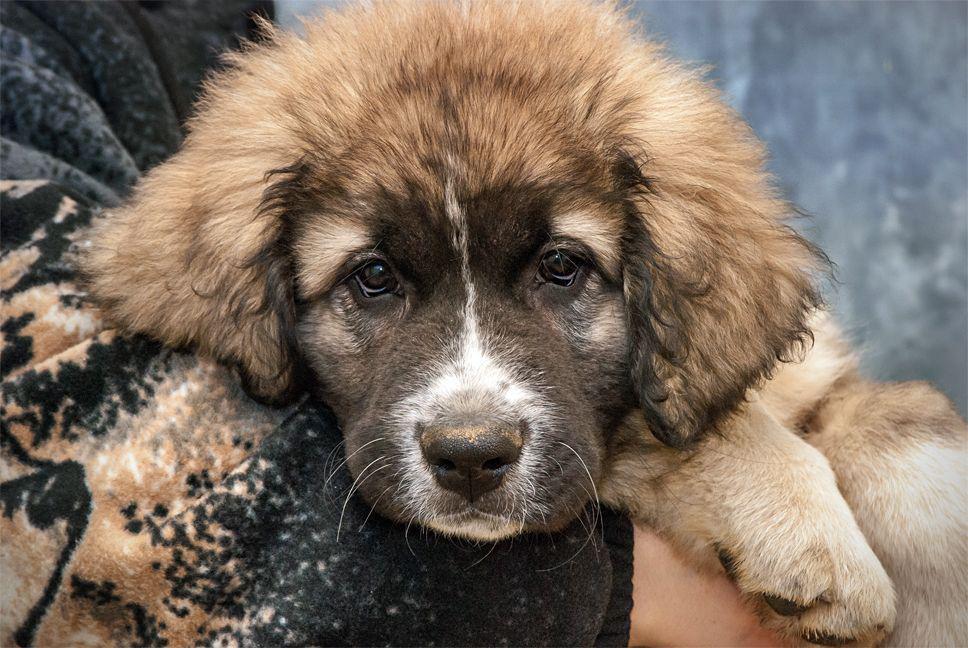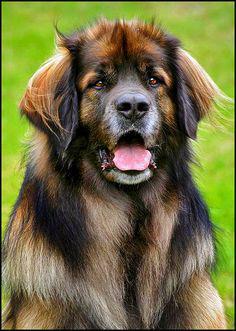The first image is the image on the left, the second image is the image on the right. Evaluate the accuracy of this statement regarding the images: "One of the dogs has its belly on the ground.". Is it true? Answer yes or no. No. 